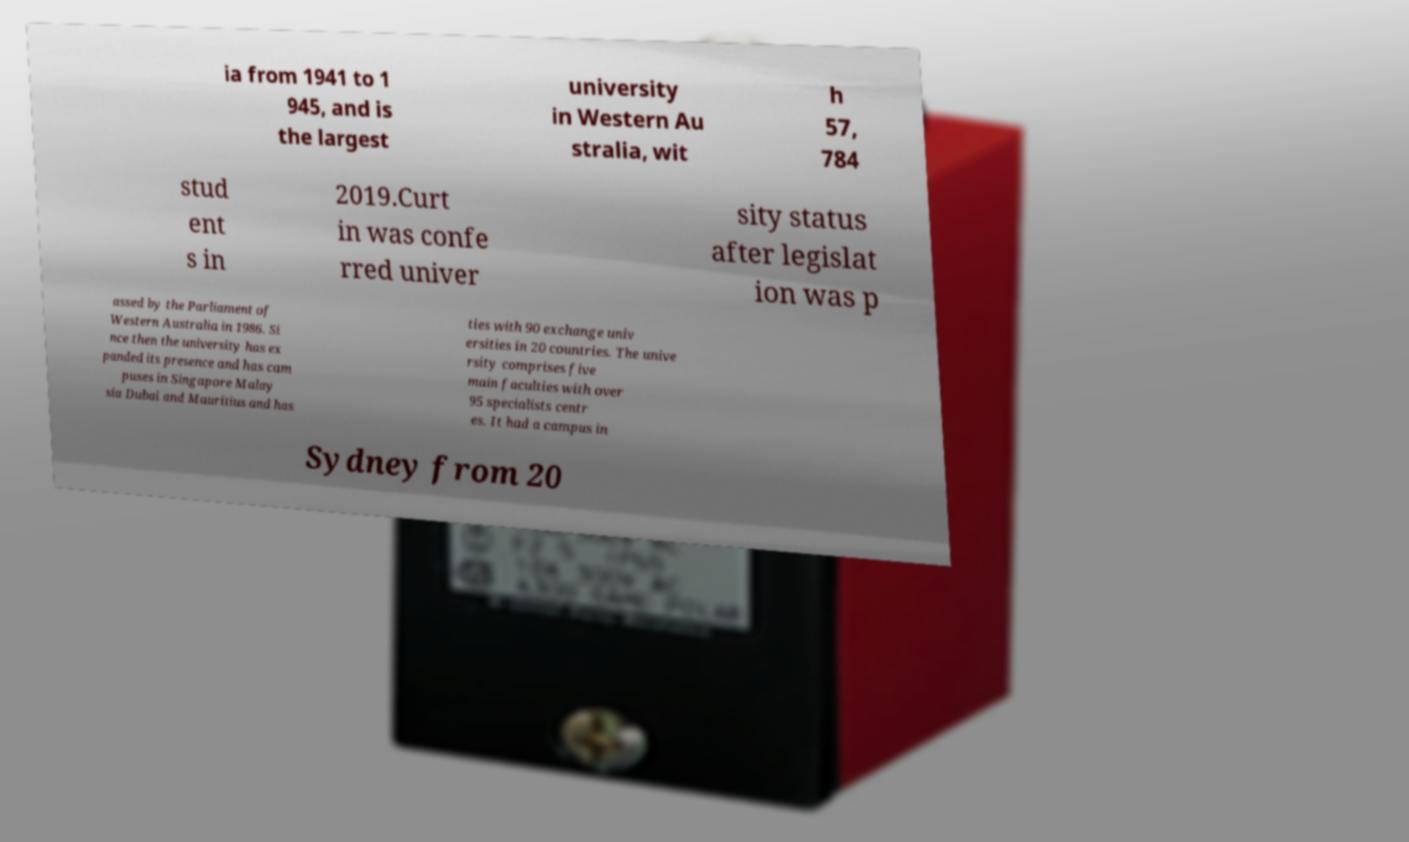Could you assist in decoding the text presented in this image and type it out clearly? ia from 1941 to 1 945, and is the largest university in Western Au stralia, wit h 57, 784 stud ent s in 2019.Curt in was confe rred univer sity status after legislat ion was p assed by the Parliament of Western Australia in 1986. Si nce then the university has ex panded its presence and has cam puses in Singapore Malay sia Dubai and Mauritius and has ties with 90 exchange univ ersities in 20 countries. The unive rsity comprises five main faculties with over 95 specialists centr es. It had a campus in Sydney from 20 